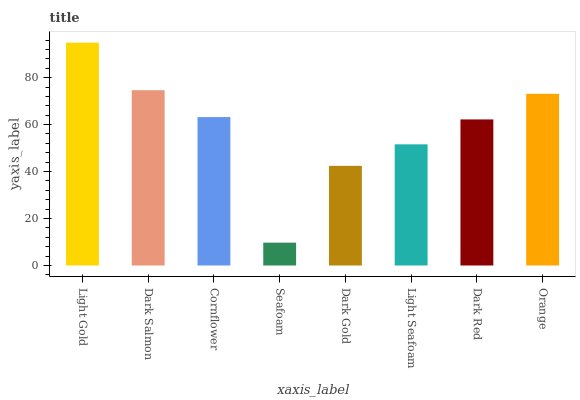Is Seafoam the minimum?
Answer yes or no. Yes. Is Light Gold the maximum?
Answer yes or no. Yes. Is Dark Salmon the minimum?
Answer yes or no. No. Is Dark Salmon the maximum?
Answer yes or no. No. Is Light Gold greater than Dark Salmon?
Answer yes or no. Yes. Is Dark Salmon less than Light Gold?
Answer yes or no. Yes. Is Dark Salmon greater than Light Gold?
Answer yes or no. No. Is Light Gold less than Dark Salmon?
Answer yes or no. No. Is Cornflower the high median?
Answer yes or no. Yes. Is Dark Red the low median?
Answer yes or no. Yes. Is Dark Salmon the high median?
Answer yes or no. No. Is Dark Salmon the low median?
Answer yes or no. No. 